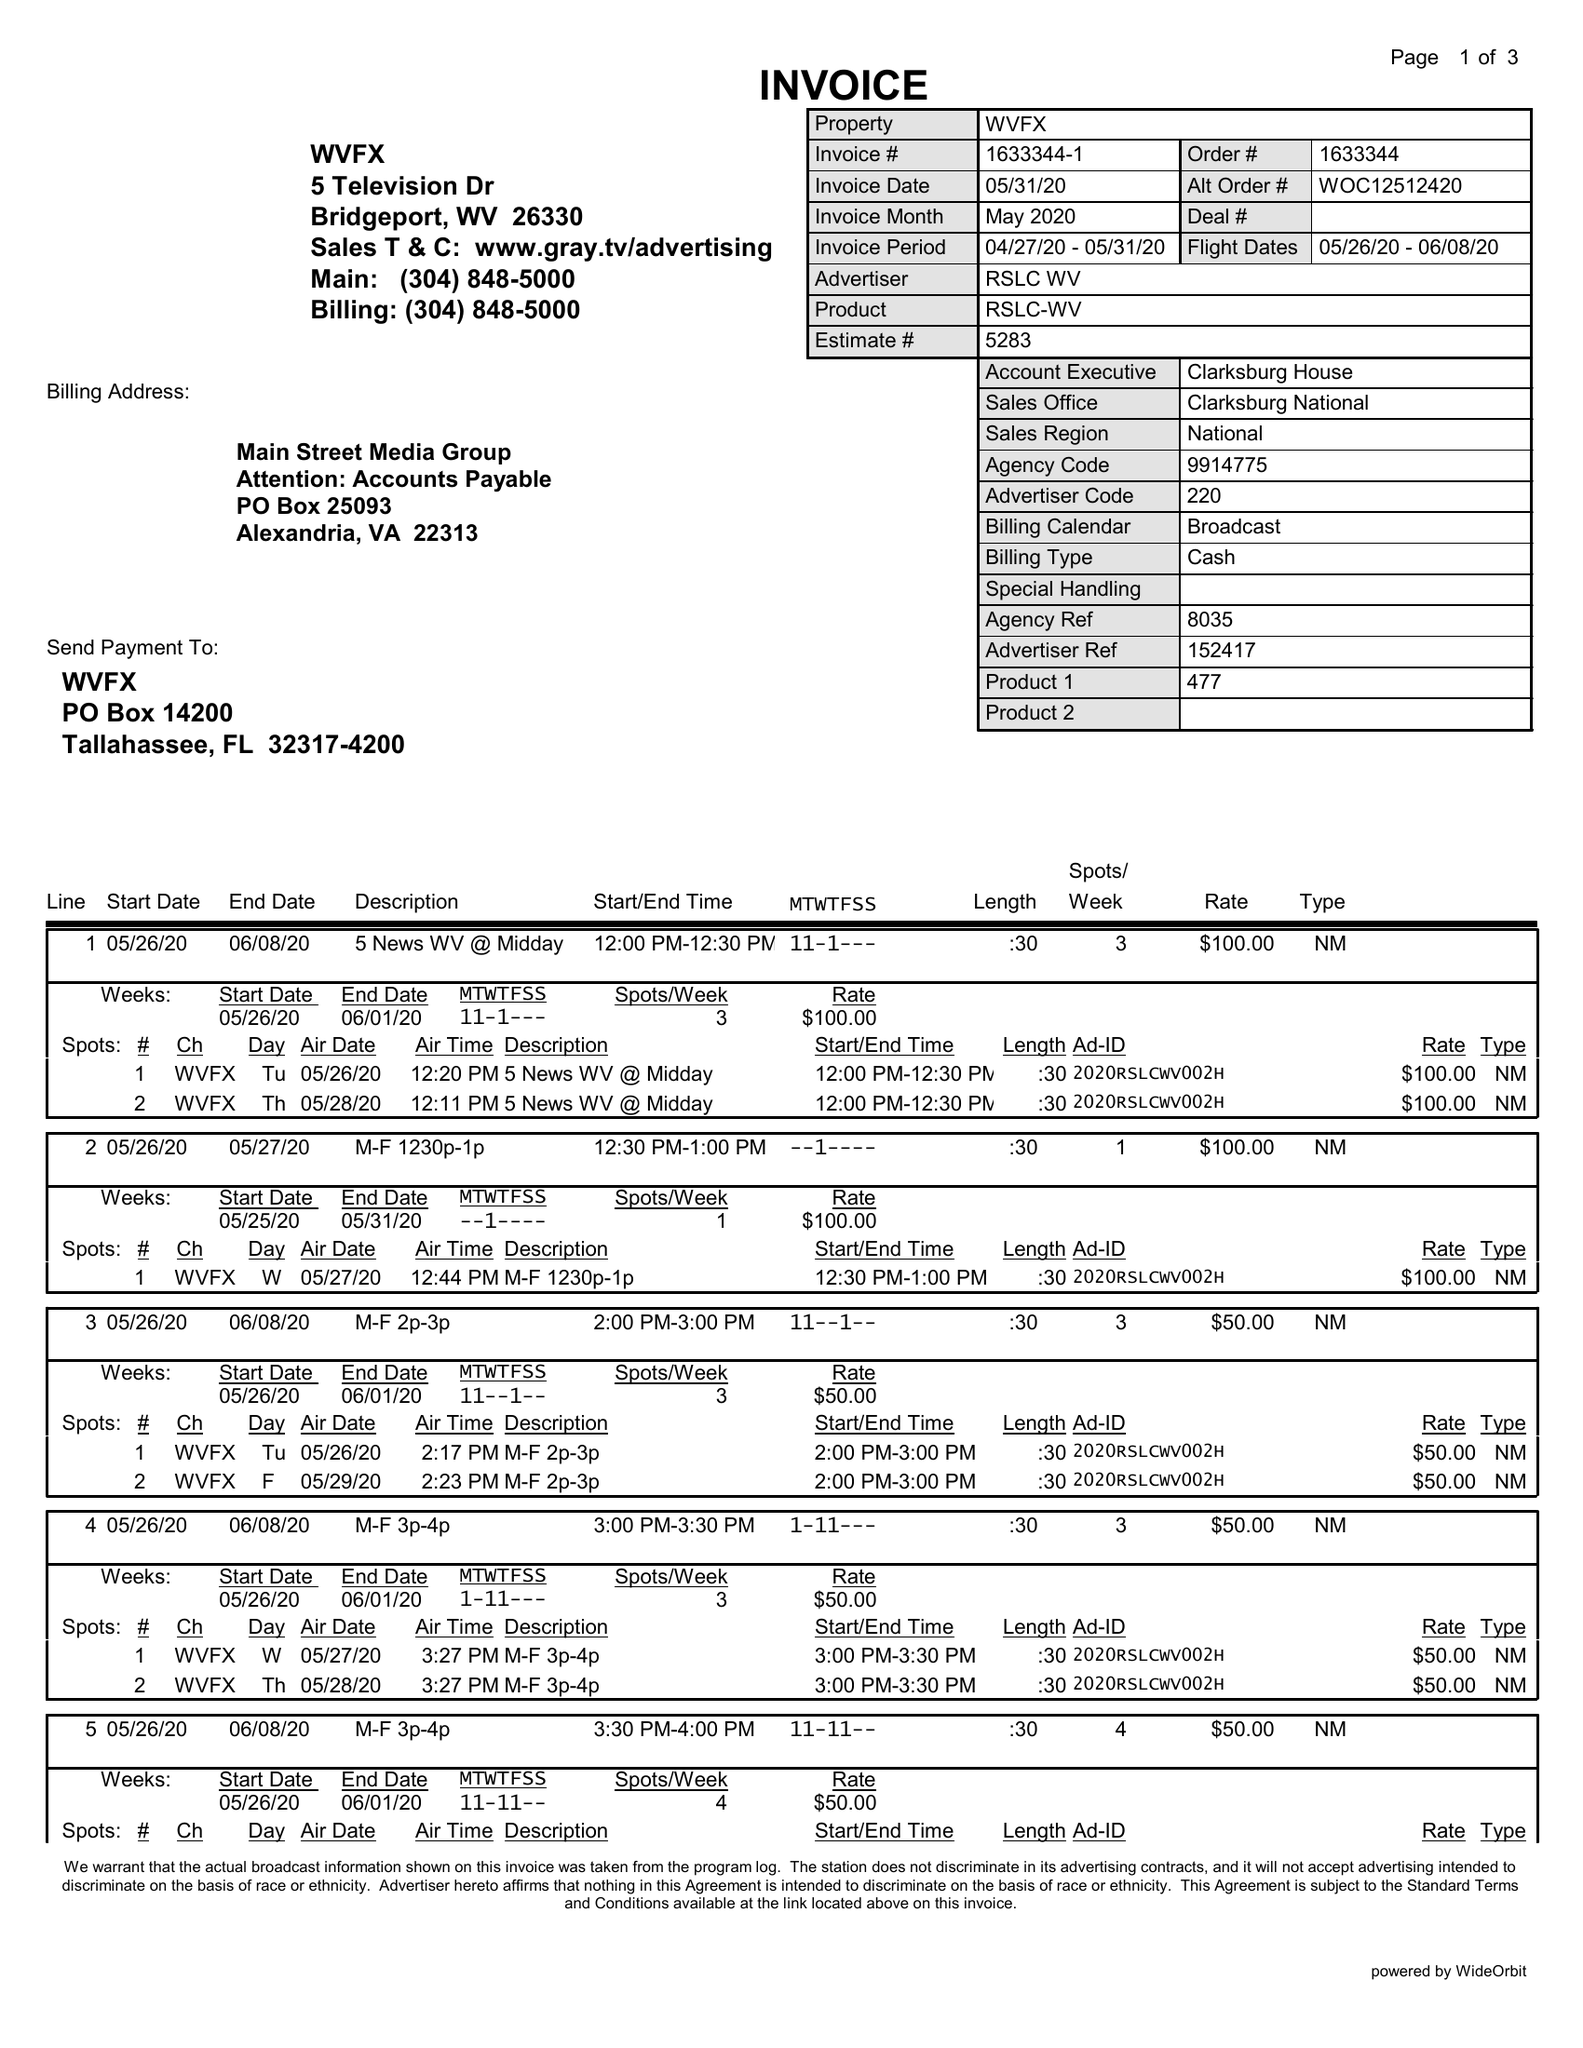What is the value for the gross_amount?
Answer the question using a single word or phrase. 3850.00 